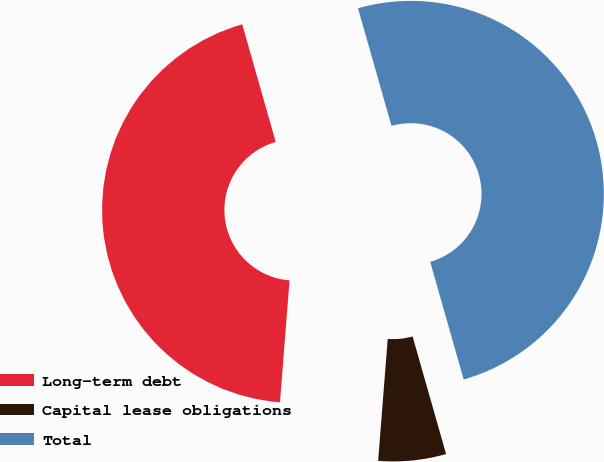Convert chart. <chart><loc_0><loc_0><loc_500><loc_500><pie_chart><fcel>Long-term debt<fcel>Capital lease obligations<fcel>Total<nl><fcel>44.34%<fcel>5.66%<fcel>50.0%<nl></chart> 